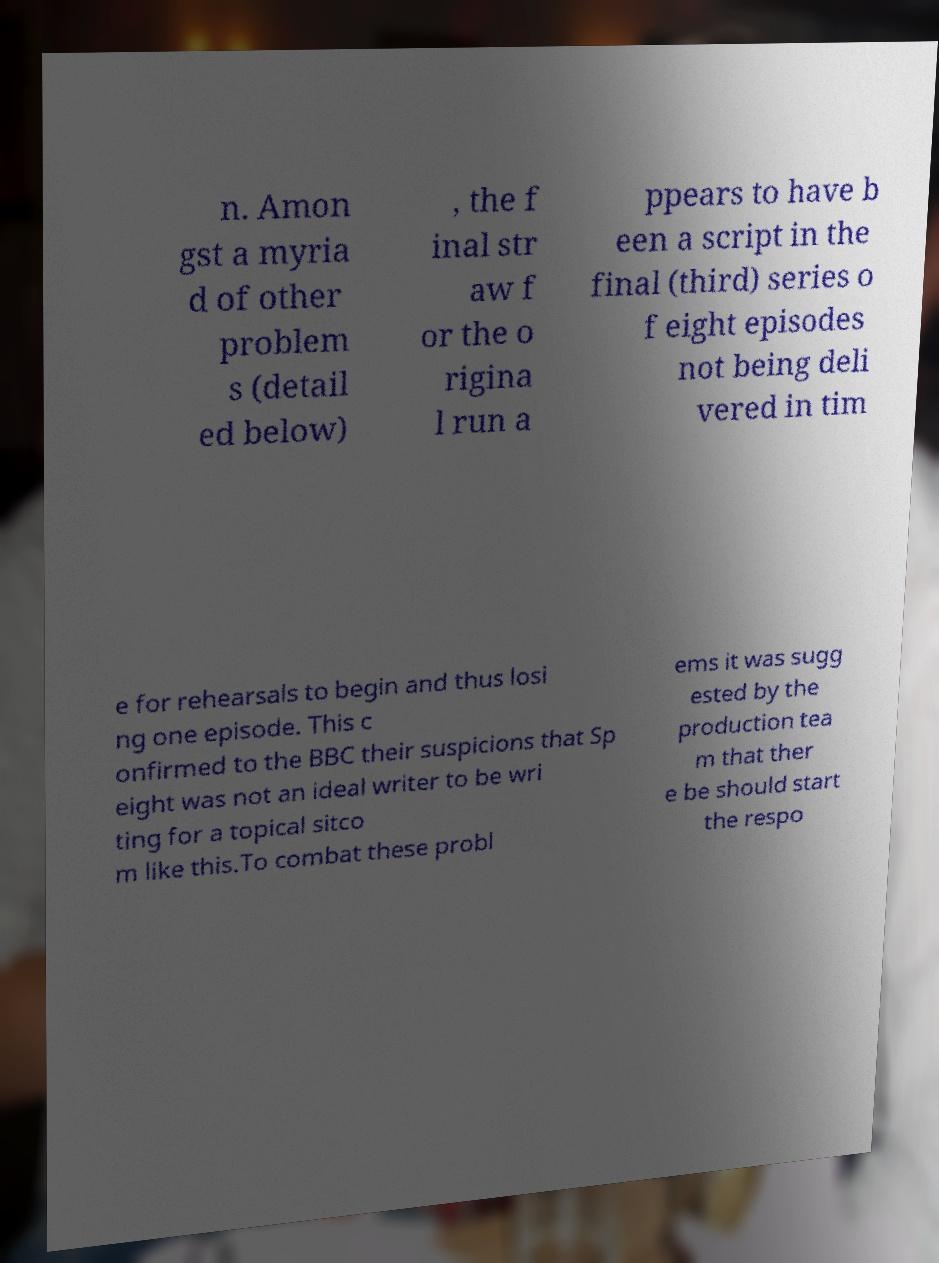What messages or text are displayed in this image? I need them in a readable, typed format. n. Amon gst a myria d of other problem s (detail ed below) , the f inal str aw f or the o rigina l run a ppears to have b een a script in the final (third) series o f eight episodes not being deli vered in tim e for rehearsals to begin and thus losi ng one episode. This c onfirmed to the BBC their suspicions that Sp eight was not an ideal writer to be wri ting for a topical sitco m like this.To combat these probl ems it was sugg ested by the production tea m that ther e be should start the respo 